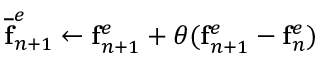<formula> <loc_0><loc_0><loc_500><loc_500>\overline { f } _ { n + 1 } ^ { e } \leftarrow f _ { n + 1 } ^ { e } + \theta ( f _ { n + 1 } ^ { e } - f _ { n } ^ { e } )</formula> 